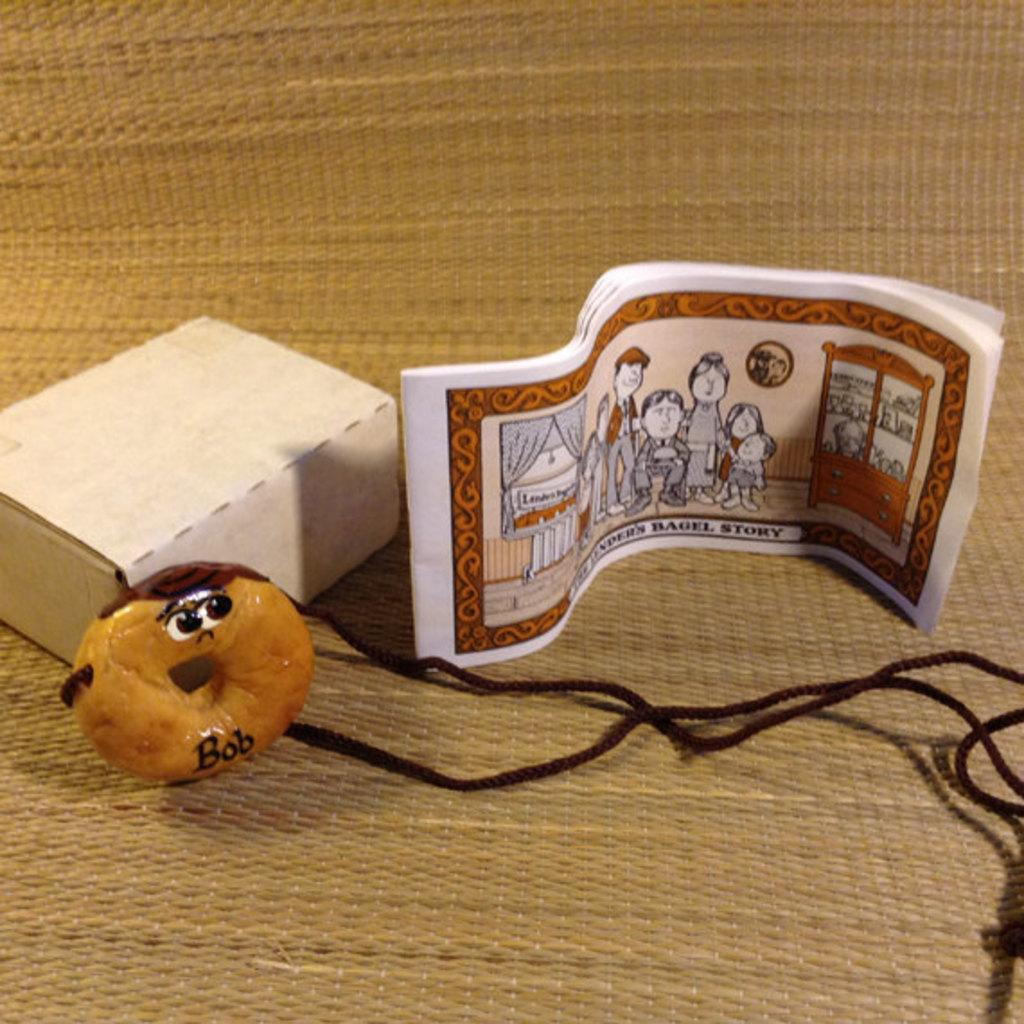What type of toy can be seen in the image? There is a toy with a rope in the image. What other objects are present in the image? There is a cardboard box and a book in the image. On what surface are the objects placed? The objects are placed on a mat. What type of pain is the toy experiencing in the image? The toy does not appear to be experiencing any pain in the image. 